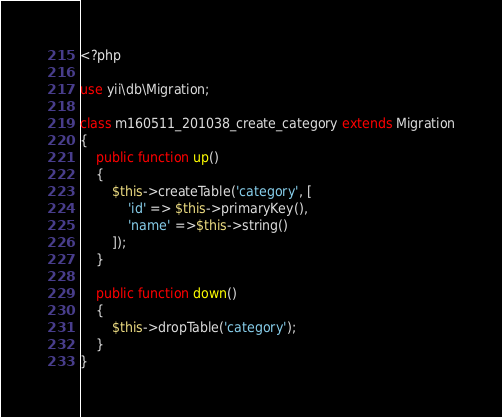Convert code to text. <code><loc_0><loc_0><loc_500><loc_500><_PHP_><?php

use yii\db\Migration;

class m160511_201038_create_category extends Migration
{
    public function up()
    {
        $this->createTable('category', [
            'id' => $this->primaryKey(),
            'name' =>$this->string()
        ]);
    }

    public function down()
    {
        $this->dropTable('category');
    }
}
</code> 